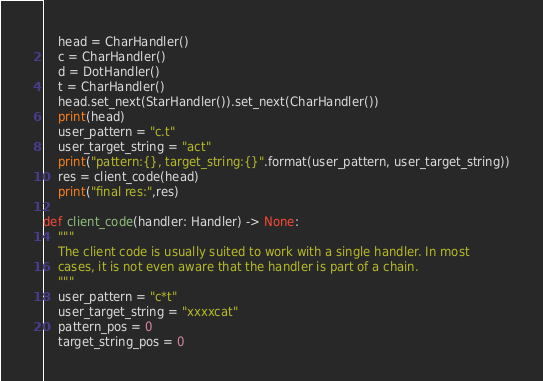<code> <loc_0><loc_0><loc_500><loc_500><_Python_>    head = CharHandler()
    c = CharHandler()
    d = DotHandler()
    t = CharHandler()
    head.set_next(StarHandler()).set_next(CharHandler())
    print(head)
    user_pattern = "c.t"
    user_target_string = "act"
    print("pattern:{}, target_string:{}".format(user_pattern, user_target_string))
    res = client_code(head)
    print("final res:",res)

def client_code(handler: Handler) -> None:
    """
    The client code is usually suited to work with a single handler. In most
    cases, it is not even aware that the handler is part of a chain.
    """
    user_pattern = "c*t"
    user_target_string = "xxxxcat"
    pattern_pos = 0
    target_string_pos = 0</code> 